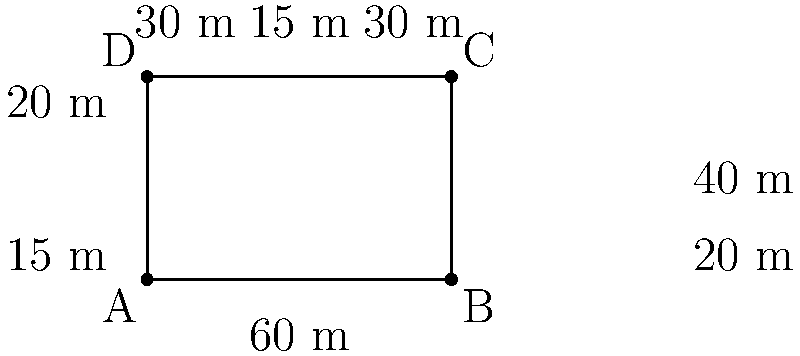As a curious high school student, you're visiting a historic courthouse and notice its unique shape. The building has a rectangular base with some extensions. Given the dimensions shown in the diagram, what is the perimeter of this courthouse? Let's calculate the perimeter step by step:

1) First, we need to identify all the sides that make up the outer edge of the building.

2) Starting from point A and moving clockwise:
   - AB = 60 m
   - BC = 40 m
   - CD = 60 m
   - DA = 40 m

3) However, we need to account for the extensions:
   - On the right side (BC), we add: 20 m + 20 m = 40 m
   - On the left side (DA), we add: 15 m + 15 m = 30 m
   - On the top side (CD), we add: 30 m + 30 m = 60 m
   - The bottom side (AB) remains unchanged

4) Now, let's sum up all these lengths:
   $$60 + (40 + 40) + (60 + 60) + (40 + 30) = 330$$

Therefore, the total perimeter of the courthouse is 330 meters.
Answer: 330 m 